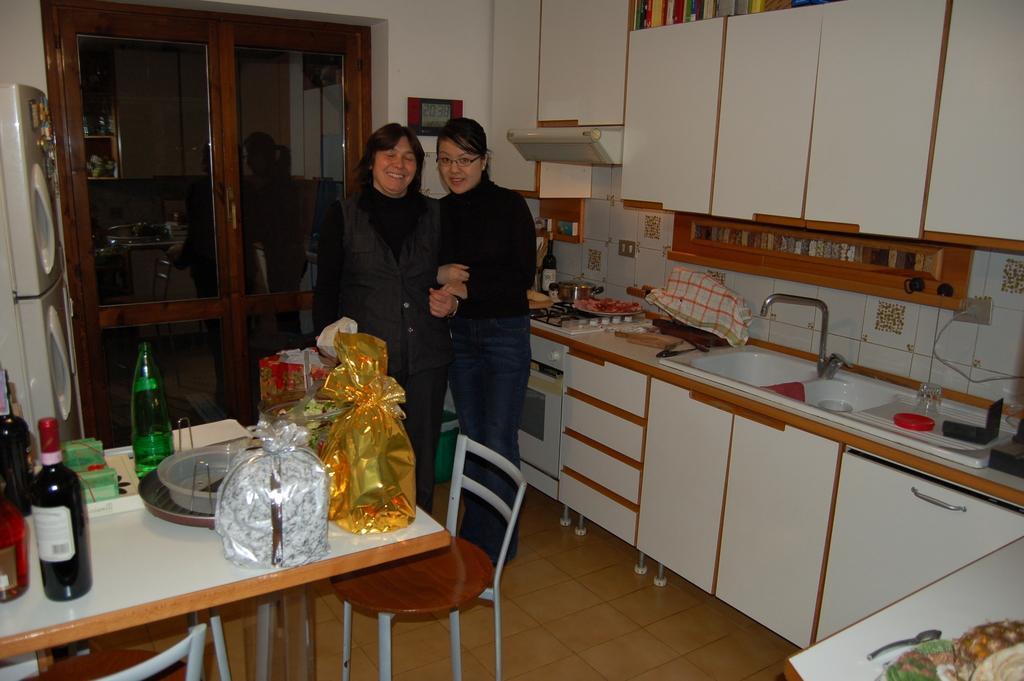How would you summarize this image in a sentence or two? In this image there are two people standing and smiling. There are bottles, bowls on the table. There is a refrigerator at the back of the table. At the right top there is a cupboard, at the right bottom there is a sink, glass, bottle and a cloth. At the back of the two persons there is a door. 